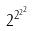<formula> <loc_0><loc_0><loc_500><loc_500>2 ^ { 2 ^ { 2 ^ { 2 } } }</formula> 